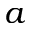<formula> <loc_0><loc_0><loc_500><loc_500>a</formula> 